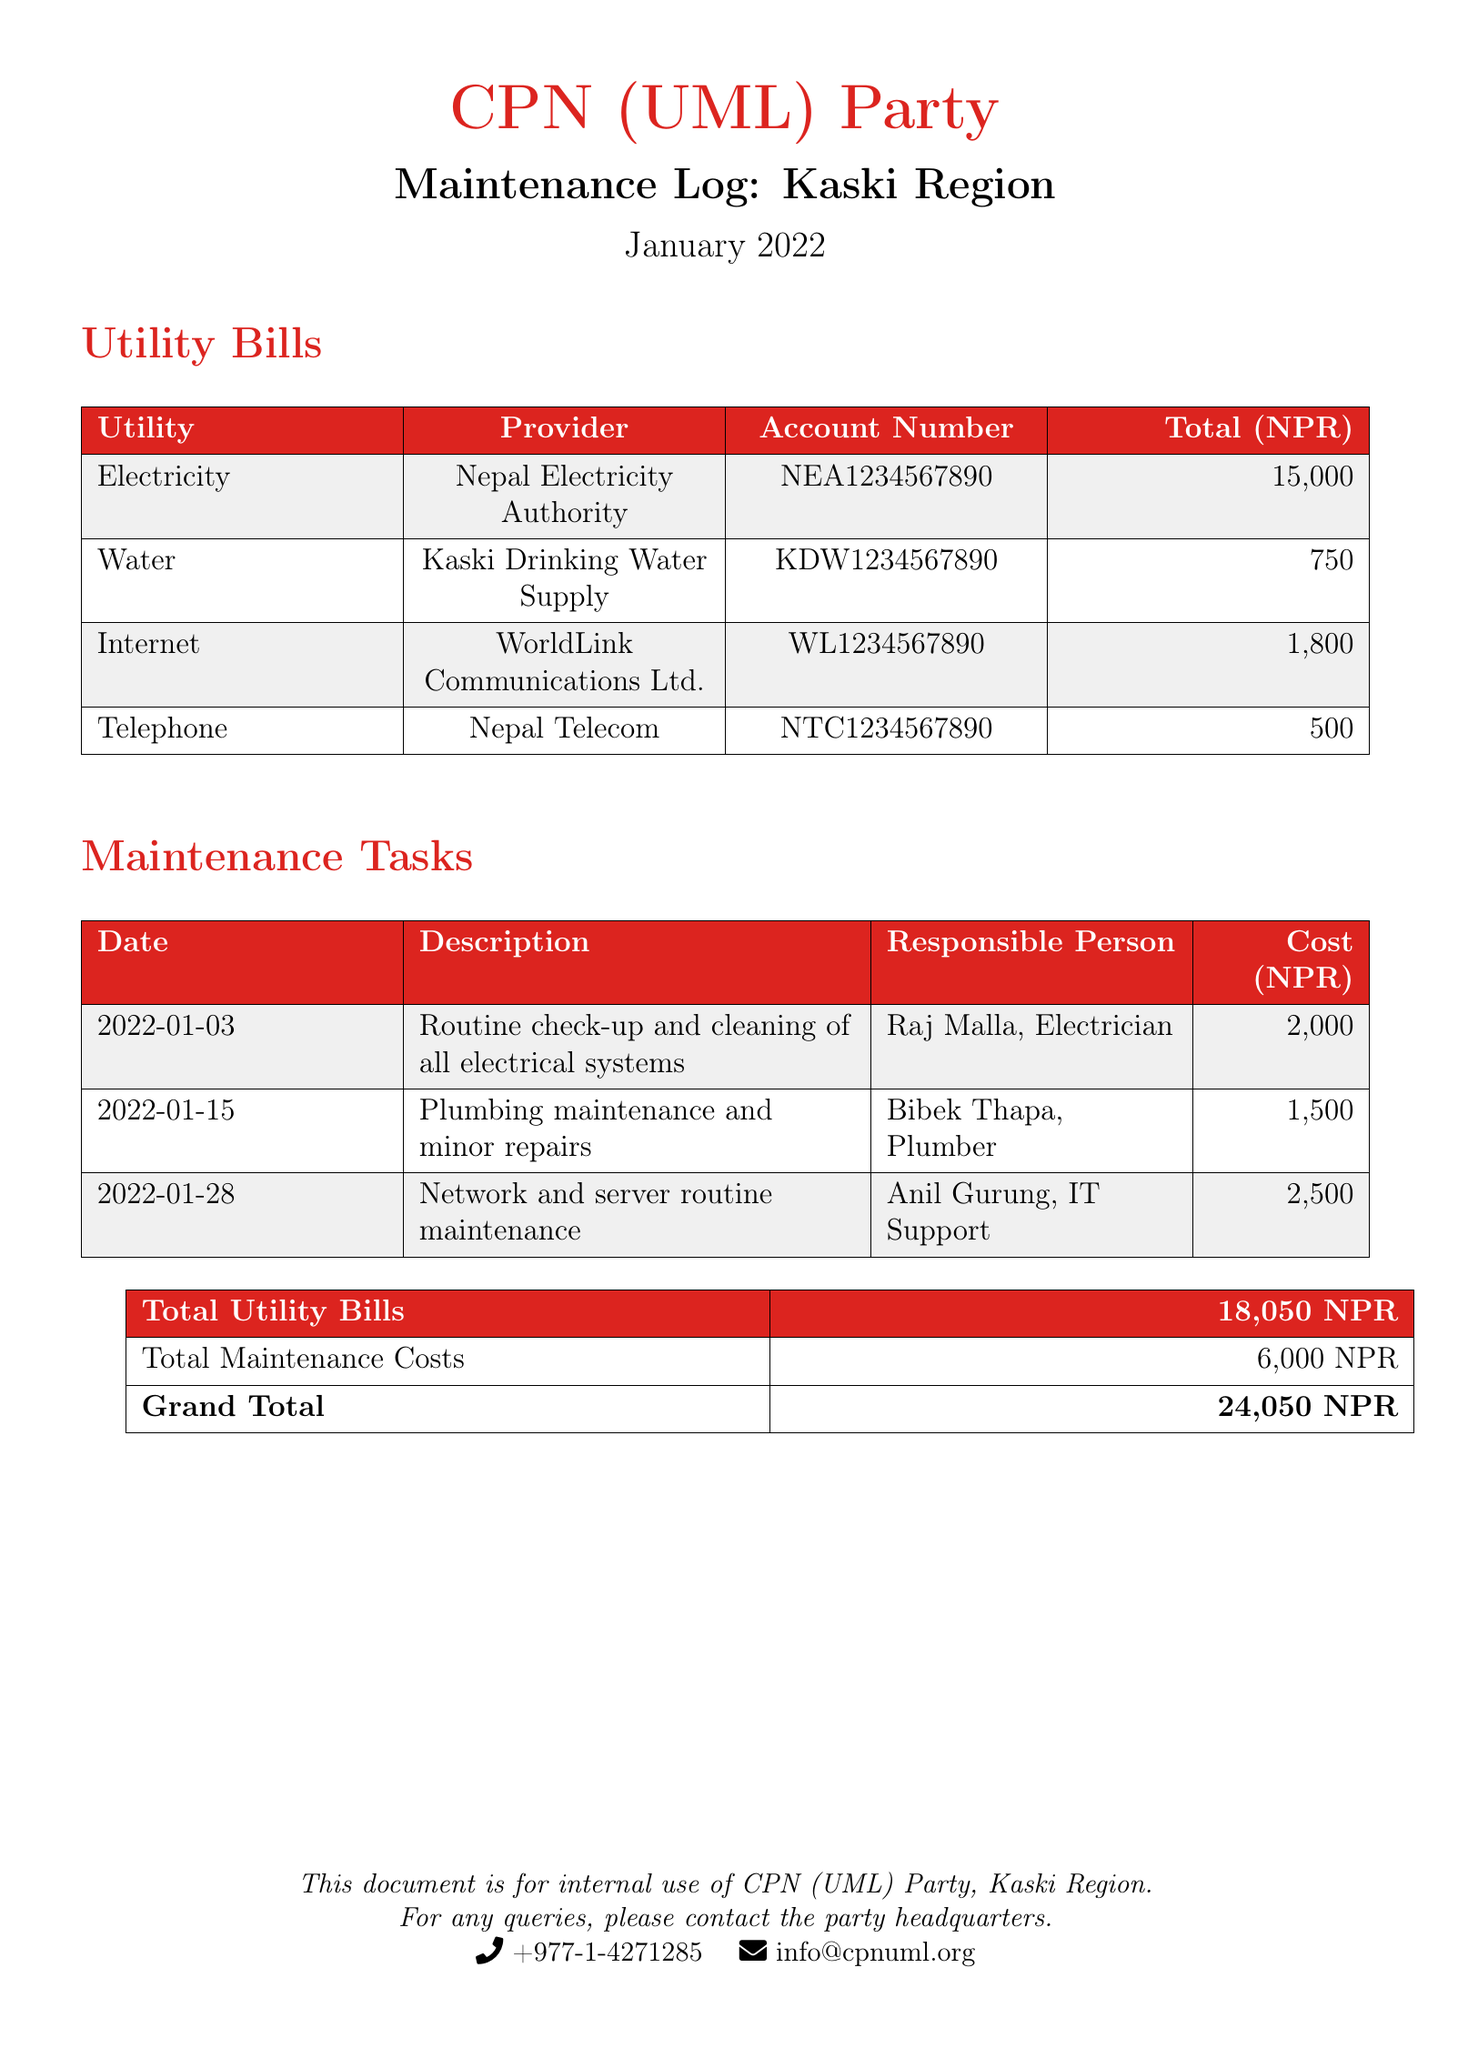What is the total amount for electricity? The total amount for electricity is stated in the utility bills section.
Answer: 15,000 Who is responsible for the plumbing maintenance? The document lists the responsible person for plumbing maintenance in the maintenance tasks section.
Answer: Bibek Thapa What was the cost of network and server routine maintenance? The cost can be found in the maintenance tasks table under the corresponding description.
Answer: 2,500 What is the account number for internet service? The account number for internet service is provided in the utility bills section.
Answer: WL1234567890 What is the grand total of all expenses? The grand total is calculated from the total utility bills and total maintenance costs provided at the end of the document.
Answer: 24,050 How many utility bills are listed in the document? The document includes a utility bills table with a specific number of entries listed there.
Answer: 4 What type of tasks are included in the maintenance logs? The tasks mentioned in the maintenance logs are detailed in the description column of the maintenance tasks table.
Answer: Electrical, plumbing, network When was the routine check-up and cleaning performed? The date for the routine check-up and cleaning is noted in the maintenance tasks section.
Answer: 2022-01-03 What is the total maintenance cost? The total maintenance cost is summed up from all individual maintenance tasks listed.
Answer: 6,000 